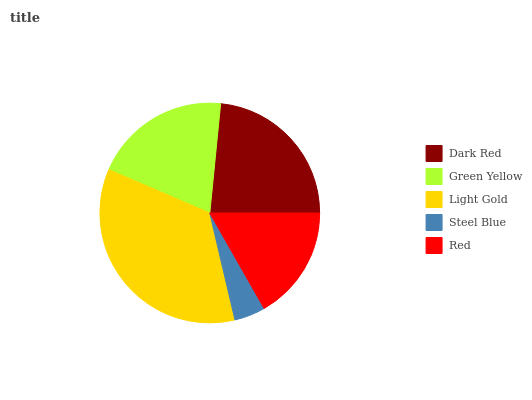Is Steel Blue the minimum?
Answer yes or no. Yes. Is Light Gold the maximum?
Answer yes or no. Yes. Is Green Yellow the minimum?
Answer yes or no. No. Is Green Yellow the maximum?
Answer yes or no. No. Is Dark Red greater than Green Yellow?
Answer yes or no. Yes. Is Green Yellow less than Dark Red?
Answer yes or no. Yes. Is Green Yellow greater than Dark Red?
Answer yes or no. No. Is Dark Red less than Green Yellow?
Answer yes or no. No. Is Green Yellow the high median?
Answer yes or no. Yes. Is Green Yellow the low median?
Answer yes or no. Yes. Is Light Gold the high median?
Answer yes or no. No. Is Dark Red the low median?
Answer yes or no. No. 